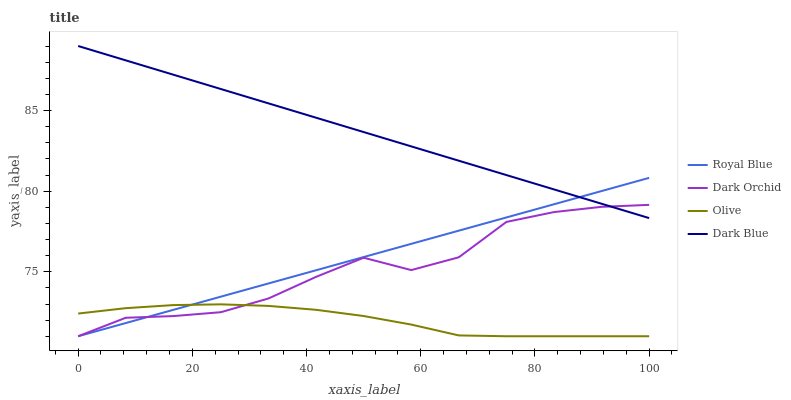Does Royal Blue have the minimum area under the curve?
Answer yes or no. No. Does Royal Blue have the maximum area under the curve?
Answer yes or no. No. Is Dark Orchid the smoothest?
Answer yes or no. No. Is Royal Blue the roughest?
Answer yes or no. No. Does Dark Blue have the lowest value?
Answer yes or no. No. Does Royal Blue have the highest value?
Answer yes or no. No. Is Olive less than Dark Blue?
Answer yes or no. Yes. Is Dark Blue greater than Olive?
Answer yes or no. Yes. Does Olive intersect Dark Blue?
Answer yes or no. No. 